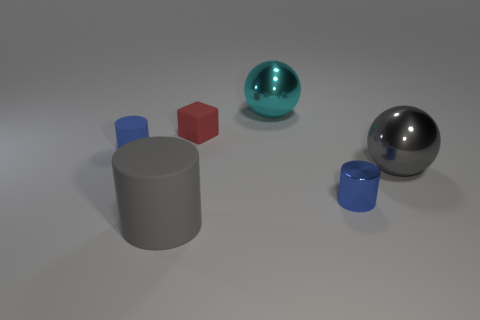If these objects were part of a physics experiment, what concept could they be used to demonstrate? If part of a physics experiment, these objects could be used to demonstrate properties such as reflection, density, material composition, or geometric principles related to volume and surface area. 